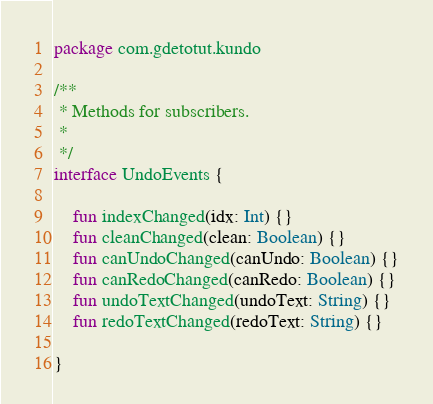Convert code to text. <code><loc_0><loc_0><loc_500><loc_500><_Kotlin_>package com.gdetotut.kundo

/**
 * Methods for subscribers.
 *
 */
interface UndoEvents {

    fun indexChanged(idx: Int) {}
    fun cleanChanged(clean: Boolean) {}
    fun canUndoChanged(canUndo: Boolean) {}
    fun canRedoChanged(canRedo: Boolean) {}
    fun undoTextChanged(undoText: String) {}
    fun redoTextChanged(redoText: String) {}

}
</code> 